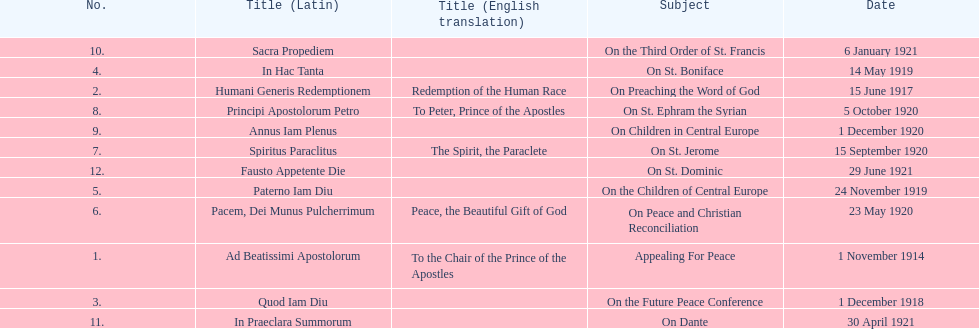What is the next title listed after sacra propediem? In Praeclara Summorum. 